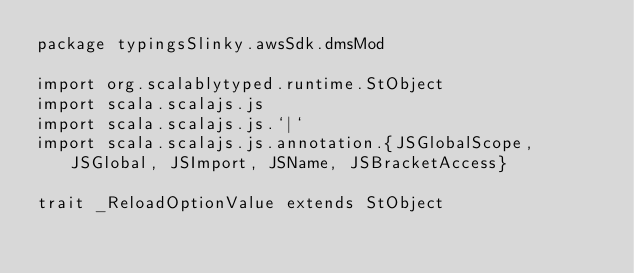<code> <loc_0><loc_0><loc_500><loc_500><_Scala_>package typingsSlinky.awsSdk.dmsMod

import org.scalablytyped.runtime.StObject
import scala.scalajs.js
import scala.scalajs.js.`|`
import scala.scalajs.js.annotation.{JSGlobalScope, JSGlobal, JSImport, JSName, JSBracketAccess}

trait _ReloadOptionValue extends StObject
</code> 